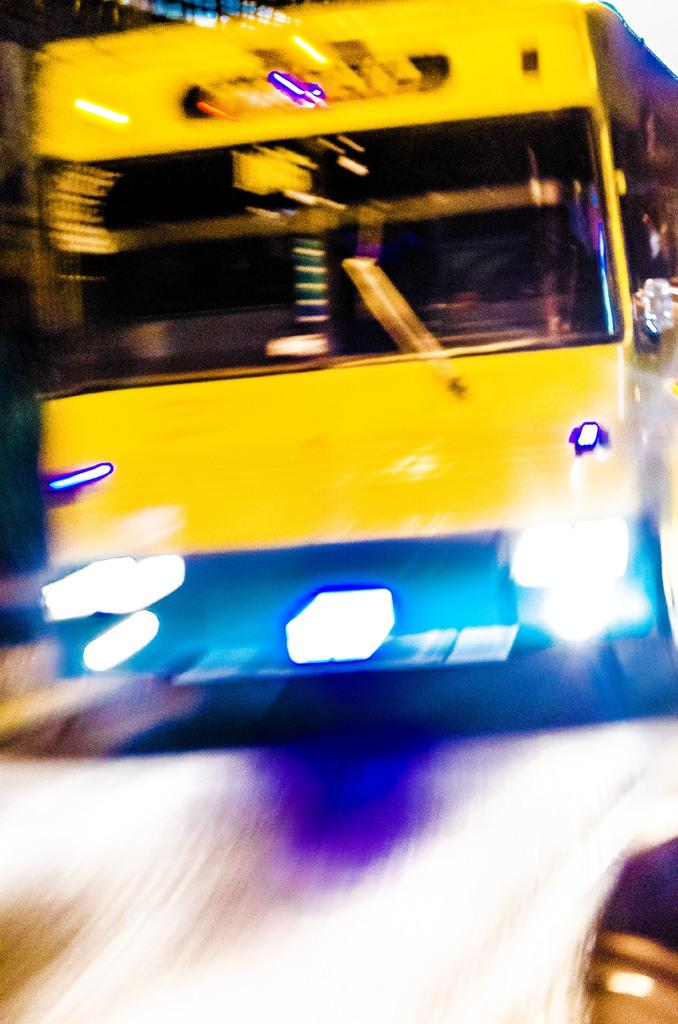What type of vehicle is in the image? There is a yellow color bus in the image. Can you hear the sound of thunder in the image? There is no sound present in the image, and therefore no thunder can be heard. What type of nut is stored in the crate in the image? There is no crate or nut present in the image; it only features a yellow color bus. 